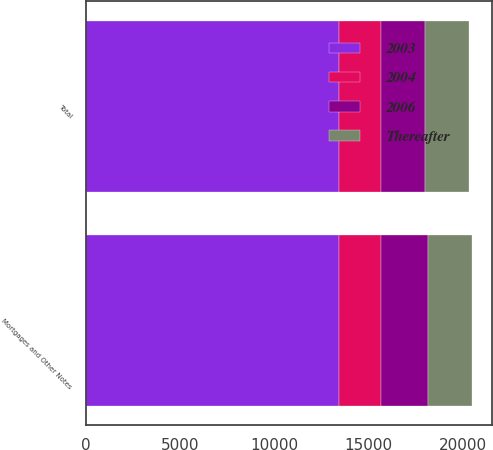Convert chart. <chart><loc_0><loc_0><loc_500><loc_500><stacked_bar_chart><ecel><fcel>Mortgages and Other Notes<fcel>Total<nl><fcel>2003<fcel>13432<fcel>13432<nl><fcel>2004<fcel>2241<fcel>2241<nl><fcel>Thereafter<fcel>2318<fcel>2318<nl><fcel>2006<fcel>2491<fcel>2318<nl></chart> 